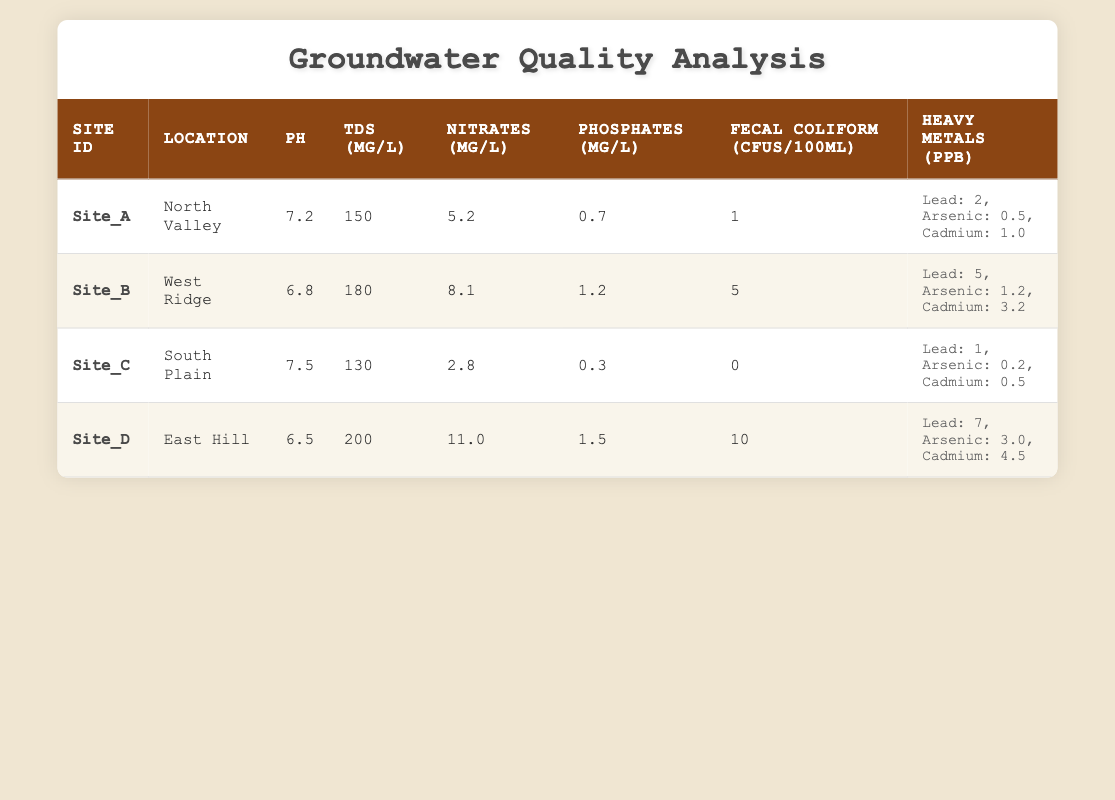What is the pH value at Site_B? The table shows that Site_B has a pH value listed in the corresponding column; it is specifically stated as 6.8.
Answer: 6.8 What is the TDS level at Site_C? In the table, Site_C has its TDS level mentioned in the TDS (mg/L) column, which reads 130.
Answer: 130 At which site was the highest concentration of Nitrates measured? To determine the site with the highest Nitrates, I will compare the Nitrates values for all sites: Site_A (5.2), Site_B (8.1), Site_C (2.8), and Site_D (11.0). Site_D has the highest value at 11.0 mg/L.
Answer: Site_D Is the Fecal Coliform count at Site_A less than at Site_D? The Fecal Coliform CFUs for Site_A is 1 and for Site_D is 10. Since 1 is less than 10, the statement is true.
Answer: Yes What is the average concentration of Lead across all sites? The Lead concentrations for each site are: Site_A (2), Site_B (5), Site_C (1), and Site_D (7). To find the average: Sum them up (2 + 5 + 1 + 7 = 15) and divide by the number of sites (4). The average is 15/4 = 3.75.
Answer: 3.75 Which site has the lowest concentration of Phosphates? The table lists the Phosphates concentrations as follows: Site_A (0.7), Site_B (1.2), Site_C (0.3), and Site_D (1.5). Comparing these values shows Site_C has the lowest Phosphates at 0.3 mg/L.
Answer: Site_C Are the levels of Arsenic at Site_B higher than those at Site_C? According to the table, the Arsenic level at Site_B is 1.2 ppb, and at Site_C, it is 0.2 ppb. Since 1.2 is greater than 0.2, the statement is true.
Answer: Yes What is the combined concentration of Heavy Metals at Site_D? The table provides the concentrations of Heavy Metals for Site_D as Lead (7 ppb), Arsenic (3 ppb), and Cadmium (4.5 ppb). Adding these gives 7 + 3 + 4.5 = 14.5 ppb as the combined concentration.
Answer: 14.5 Is the TDS level at Site_A higher than at Site_C? The TDS levels are given as: Site_A is 150 mg/L and Site_C is 130 mg/L. Since 150 is greater than 130, the statement is true.
Answer: Yes 